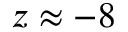Convert formula to latex. <formula><loc_0><loc_0><loc_500><loc_500>z \approx - 8</formula> 